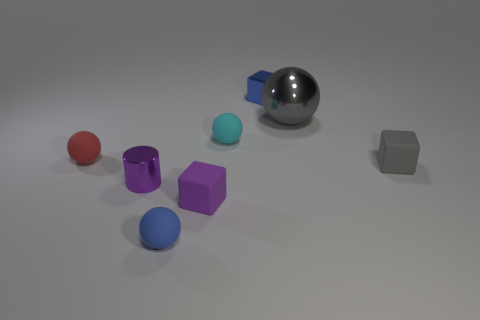What number of gray cylinders are there?
Make the answer very short. 0. How big is the blue thing behind the cyan matte sphere?
Your answer should be very brief. Small. Are there the same number of cyan rubber balls behind the gray metal sphere and small green spheres?
Your response must be concise. Yes. Are there any purple things of the same shape as the small red rubber object?
Your response must be concise. No. There is a small object that is on the left side of the tiny blue rubber thing and behind the purple shiny cylinder; what is its shape?
Make the answer very short. Sphere. Do the purple cube and the blue thing on the right side of the tiny purple matte thing have the same material?
Provide a short and direct response. No. There is a big gray ball; are there any small cyan matte spheres right of it?
Provide a succinct answer. No. What number of objects are either blue metallic cubes or small blocks behind the tiny red sphere?
Make the answer very short. 1. There is a shiny thing left of the small rubber ball on the right side of the tiny blue matte thing; what is its color?
Keep it short and to the point. Purple. How many other things are made of the same material as the large object?
Make the answer very short. 2. 